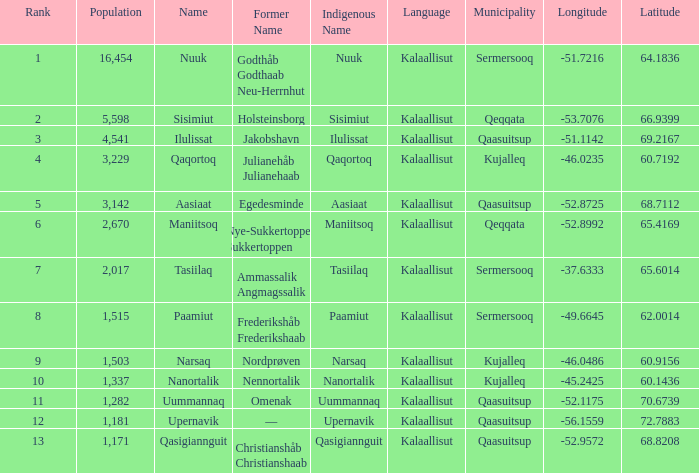Who has a former name of nordprøven? Narsaq. 